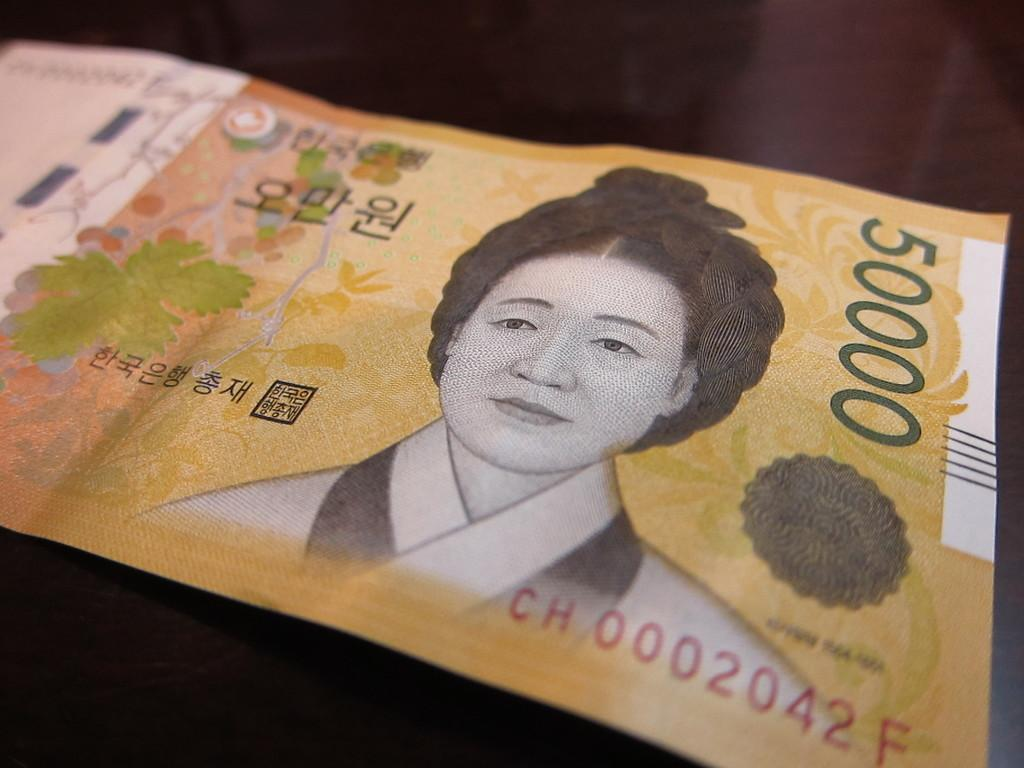What is the main object in the picture? There is a currency note in the picture. What can be found on the currency note? There is text and a picture of a person on the currency note. What type of chair is depicted on the currency note? There is no chair depicted on the currency note; it only features text and a picture of a person. 